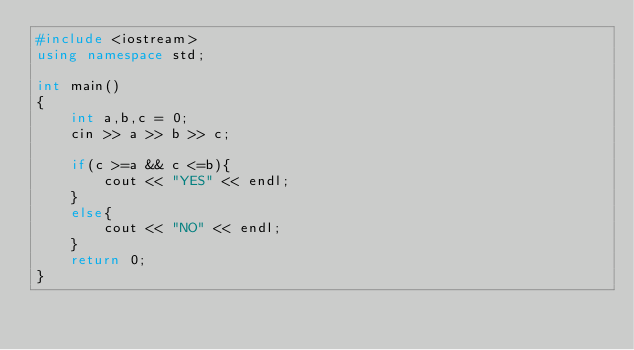Convert code to text. <code><loc_0><loc_0><loc_500><loc_500><_C++_>#include <iostream>
using namespace std;

int main()
{
    int a,b,c = 0;
    cin >> a >> b >> c;
    
    if(c >=a && c <=b){
        cout << "YES" << endl;
    }
    else{
        cout << "NO" << endl;
    }
    return 0;
}</code> 